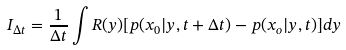Convert formula to latex. <formula><loc_0><loc_0><loc_500><loc_500>I _ { \Delta t } = \frac { 1 } { \Delta t } \int R ( y ) [ p ( x _ { 0 } | y , t + \Delta t ) - p ( x _ { o } | y , t ) ] d y</formula> 